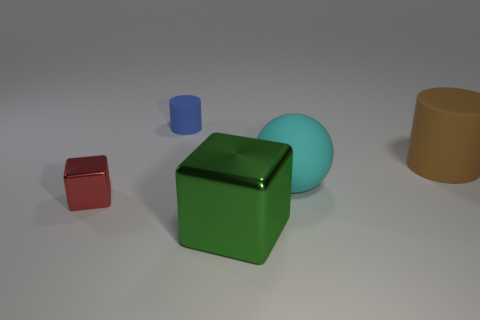How many other things are the same color as the small rubber object?
Your answer should be very brief. 0. Are there fewer big cubes than cubes?
Your response must be concise. Yes. There is a metallic cube that is in front of the block left of the big metallic cube; how many large brown matte cylinders are behind it?
Offer a terse response. 1. What size is the matte object in front of the brown rubber thing?
Your answer should be compact. Large. There is a brown object that is behind the large cyan matte ball; does it have the same shape as the blue object?
Offer a terse response. Yes. There is a large brown thing that is the same shape as the tiny rubber object; what is its material?
Make the answer very short. Rubber. Is there a large purple object?
Your answer should be very brief. No. There is a small thing that is on the right side of the metal thing to the left of the metal block that is on the right side of the tiny blue cylinder; what is its material?
Provide a succinct answer. Rubber. Is the shape of the brown matte object the same as the matte thing behind the big brown matte object?
Keep it short and to the point. Yes. How many small blue rubber things are the same shape as the brown matte thing?
Make the answer very short. 1. 